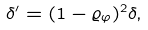<formula> <loc_0><loc_0><loc_500><loc_500>\delta ^ { \prime } = ( 1 - \varrho _ { \varphi } ) ^ { 2 } \delta ,</formula> 